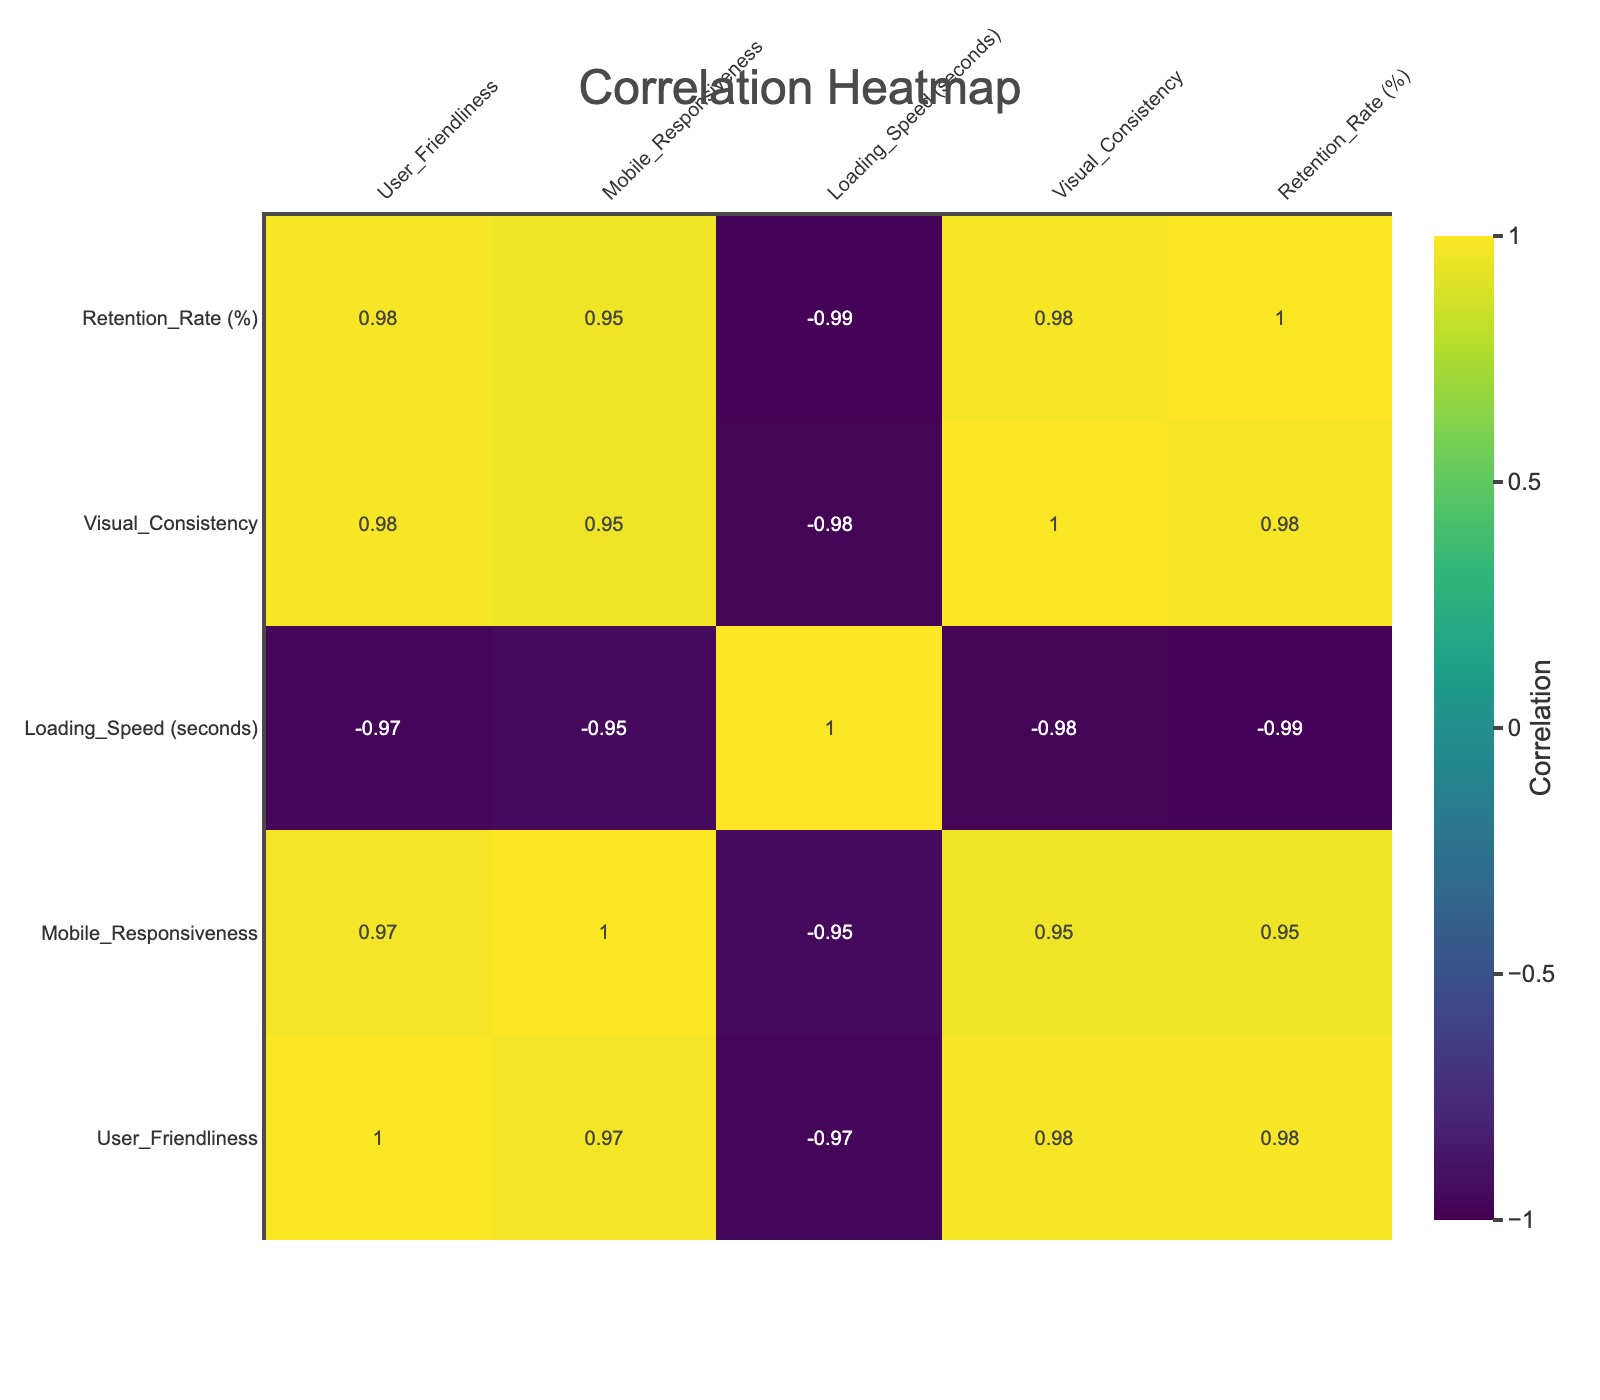What is the retention rate for high design aesthetics websites? From the table, the data points for high design aesthetics are 75, 80, 78, and 76. Therefore, the retention rate for high design aesthetics websites varies from these values.
Answer: 75, 80, 78, 76 What is the average loading speed for medium design aesthetics websites? The loading speeds for medium design aesthetics are 3.0, 4.0, and 3.5 seconds. To find the average, we sum these values (3.0 + 4.0 + 3.5 = 10.5) and divide by the number of entries (3). Thus, 10.5 / 3 = 3.5 seconds.
Answer: 3.5 seconds Does user friendliness have a high correlation with retention rate? Observing the correlation matrix, we see that user friendliness and retention rate have a correlation value of approximately 0.78, signifying a high positive correlation.
Answer: Yes What is the range of retention rates across all design aesthetics? We look at the retention rates: 75, 60, 40, 80, 55, 35, 78, 62, 38, and 76. The highest retention rate is 80, while the lowest is 35. To find the range, we subtract the lowest from the highest (80 - 35 = 45).
Answer: 45 Which design aesthetics category has the highest average visual consistency? The visual consistency values for high, medium, and low design aesthetics are 4.8, 3.5, and 2.0; 4.9, 3.0, and 2.2; 4.7, 3.3, and 2.1; and 4.6 correspondingly. The averages for high can be calculated as follows: (4.8 + 4.9 + 4.7 + 4.6) / 4 = 4.75. For medium: (3.5 + 3.0 + 3.3) / 3 = 3.27 and for low: (2.0 + 2.2 + 2.1) / 3 = 2.10. Thus, the highest average visual consistency is for high design aesthetics at 4.75.
Answer: High Is the correlation between mobile responsiveness and retention rate positive? Looking at the correlation matrix, mobile responsiveness has a correlation value of approximately 0.6 with retention rate, indicating a positive relationship.
Answer: Yes 